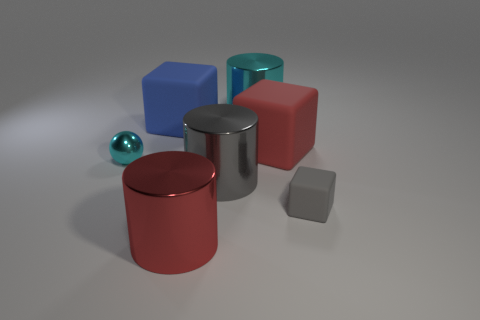Is the color of the tiny shiny object the same as the large cylinder that is behind the blue block?
Offer a very short reply. Yes. Are there any tiny cyan things that are behind the cylinder that is behind the cyan thing that is in front of the red block?
Provide a succinct answer. No. The cyan metallic object that is the same size as the gray cylinder is what shape?
Ensure brevity in your answer.  Cylinder. Does the cylinder in front of the small gray thing have the same size as the cylinder that is behind the large blue rubber block?
Offer a terse response. Yes. How many small gray rubber things are there?
Offer a very short reply. 1. There is a rubber block on the right side of the red object behind the big metallic thing in front of the gray cube; how big is it?
Keep it short and to the point. Small. There is a tiny block; what number of red matte blocks are in front of it?
Your answer should be very brief. 0. Are there an equal number of tiny matte objects left of the blue block and yellow shiny things?
Your answer should be very brief. Yes. What number of objects are either big gray things or small metallic blocks?
Your answer should be compact. 1. Is there any other thing that is the same shape as the tiny cyan shiny object?
Give a very brief answer. No. 